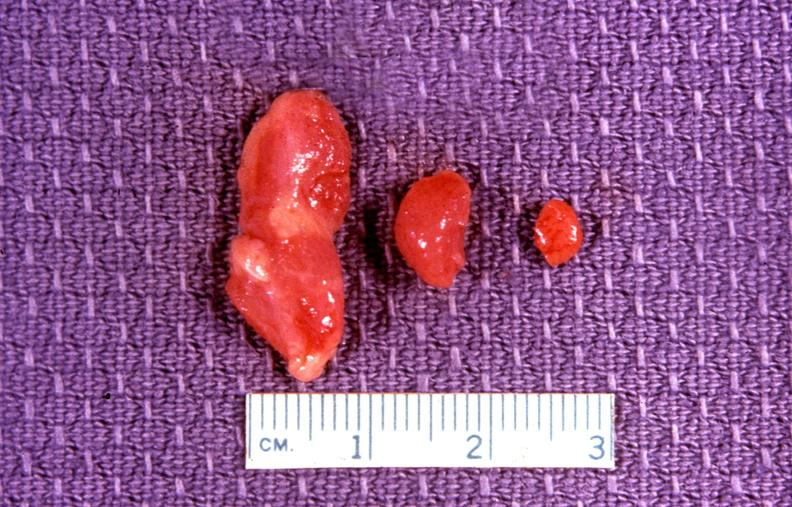what does this image show?
Answer the question using a single word or phrase. Parathyroid 